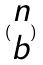<formula> <loc_0><loc_0><loc_500><loc_500>( \begin{matrix} n \\ b \end{matrix} )</formula> 